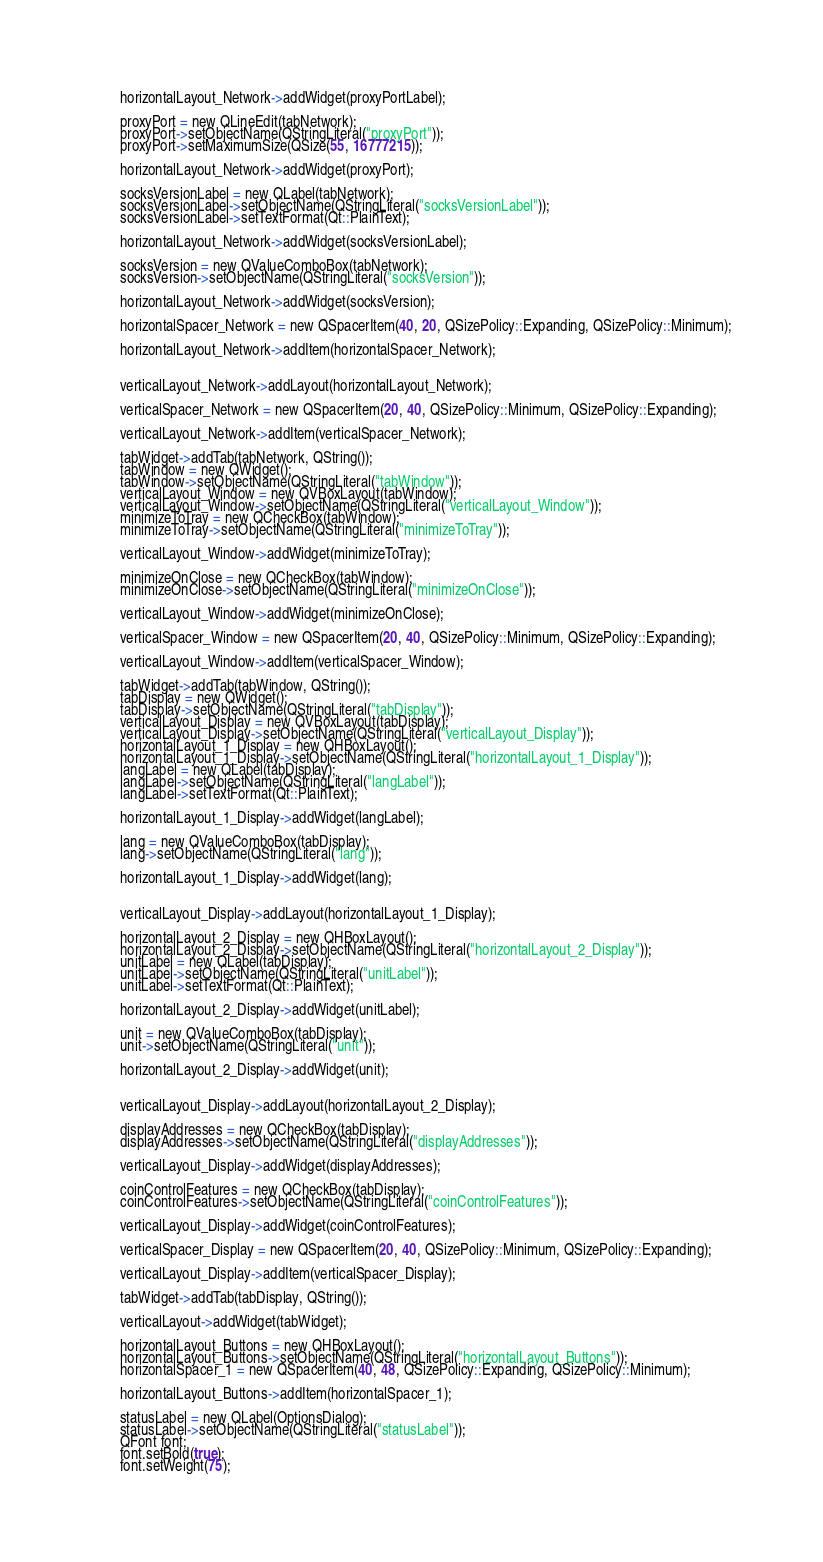<code> <loc_0><loc_0><loc_500><loc_500><_C_>        horizontalLayout_Network->addWidget(proxyPortLabel);

        proxyPort = new QLineEdit(tabNetwork);
        proxyPort->setObjectName(QStringLiteral("proxyPort"));
        proxyPort->setMaximumSize(QSize(55, 16777215));

        horizontalLayout_Network->addWidget(proxyPort);

        socksVersionLabel = new QLabel(tabNetwork);
        socksVersionLabel->setObjectName(QStringLiteral("socksVersionLabel"));
        socksVersionLabel->setTextFormat(Qt::PlainText);

        horizontalLayout_Network->addWidget(socksVersionLabel);

        socksVersion = new QValueComboBox(tabNetwork);
        socksVersion->setObjectName(QStringLiteral("socksVersion"));

        horizontalLayout_Network->addWidget(socksVersion);

        horizontalSpacer_Network = new QSpacerItem(40, 20, QSizePolicy::Expanding, QSizePolicy::Minimum);

        horizontalLayout_Network->addItem(horizontalSpacer_Network);


        verticalLayout_Network->addLayout(horizontalLayout_Network);

        verticalSpacer_Network = new QSpacerItem(20, 40, QSizePolicy::Minimum, QSizePolicy::Expanding);

        verticalLayout_Network->addItem(verticalSpacer_Network);

        tabWidget->addTab(tabNetwork, QString());
        tabWindow = new QWidget();
        tabWindow->setObjectName(QStringLiteral("tabWindow"));
        verticalLayout_Window = new QVBoxLayout(tabWindow);
        verticalLayout_Window->setObjectName(QStringLiteral("verticalLayout_Window"));
        minimizeToTray = new QCheckBox(tabWindow);
        minimizeToTray->setObjectName(QStringLiteral("minimizeToTray"));

        verticalLayout_Window->addWidget(minimizeToTray);

        minimizeOnClose = new QCheckBox(tabWindow);
        minimizeOnClose->setObjectName(QStringLiteral("minimizeOnClose"));

        verticalLayout_Window->addWidget(minimizeOnClose);

        verticalSpacer_Window = new QSpacerItem(20, 40, QSizePolicy::Minimum, QSizePolicy::Expanding);

        verticalLayout_Window->addItem(verticalSpacer_Window);

        tabWidget->addTab(tabWindow, QString());
        tabDisplay = new QWidget();
        tabDisplay->setObjectName(QStringLiteral("tabDisplay"));
        verticalLayout_Display = new QVBoxLayout(tabDisplay);
        verticalLayout_Display->setObjectName(QStringLiteral("verticalLayout_Display"));
        horizontalLayout_1_Display = new QHBoxLayout();
        horizontalLayout_1_Display->setObjectName(QStringLiteral("horizontalLayout_1_Display"));
        langLabel = new QLabel(tabDisplay);
        langLabel->setObjectName(QStringLiteral("langLabel"));
        langLabel->setTextFormat(Qt::PlainText);

        horizontalLayout_1_Display->addWidget(langLabel);

        lang = new QValueComboBox(tabDisplay);
        lang->setObjectName(QStringLiteral("lang"));

        horizontalLayout_1_Display->addWidget(lang);


        verticalLayout_Display->addLayout(horizontalLayout_1_Display);

        horizontalLayout_2_Display = new QHBoxLayout();
        horizontalLayout_2_Display->setObjectName(QStringLiteral("horizontalLayout_2_Display"));
        unitLabel = new QLabel(tabDisplay);
        unitLabel->setObjectName(QStringLiteral("unitLabel"));
        unitLabel->setTextFormat(Qt::PlainText);

        horizontalLayout_2_Display->addWidget(unitLabel);

        unit = new QValueComboBox(tabDisplay);
        unit->setObjectName(QStringLiteral("unit"));

        horizontalLayout_2_Display->addWidget(unit);


        verticalLayout_Display->addLayout(horizontalLayout_2_Display);

        displayAddresses = new QCheckBox(tabDisplay);
        displayAddresses->setObjectName(QStringLiteral("displayAddresses"));

        verticalLayout_Display->addWidget(displayAddresses);

        coinControlFeatures = new QCheckBox(tabDisplay);
        coinControlFeatures->setObjectName(QStringLiteral("coinControlFeatures"));

        verticalLayout_Display->addWidget(coinControlFeatures);

        verticalSpacer_Display = new QSpacerItem(20, 40, QSizePolicy::Minimum, QSizePolicy::Expanding);

        verticalLayout_Display->addItem(verticalSpacer_Display);

        tabWidget->addTab(tabDisplay, QString());

        verticalLayout->addWidget(tabWidget);

        horizontalLayout_Buttons = new QHBoxLayout();
        horizontalLayout_Buttons->setObjectName(QStringLiteral("horizontalLayout_Buttons"));
        horizontalSpacer_1 = new QSpacerItem(40, 48, QSizePolicy::Expanding, QSizePolicy::Minimum);

        horizontalLayout_Buttons->addItem(horizontalSpacer_1);

        statusLabel = new QLabel(OptionsDialog);
        statusLabel->setObjectName(QStringLiteral("statusLabel"));
        QFont font;
        font.setBold(true);
        font.setWeight(75);</code> 